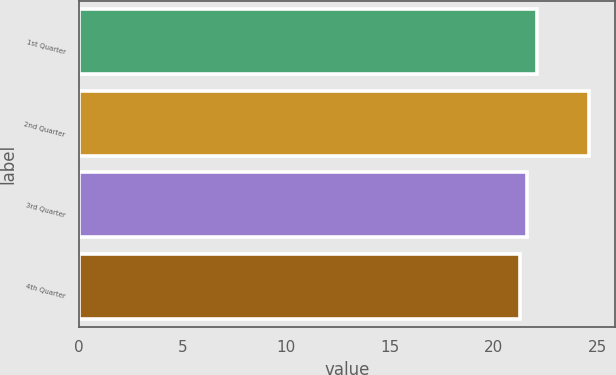Convert chart to OTSL. <chart><loc_0><loc_0><loc_500><loc_500><bar_chart><fcel>1st Quarter<fcel>2nd Quarter<fcel>3rd Quarter<fcel>4th Quarter<nl><fcel>22.07<fcel>24.6<fcel>21.59<fcel>21.25<nl></chart> 